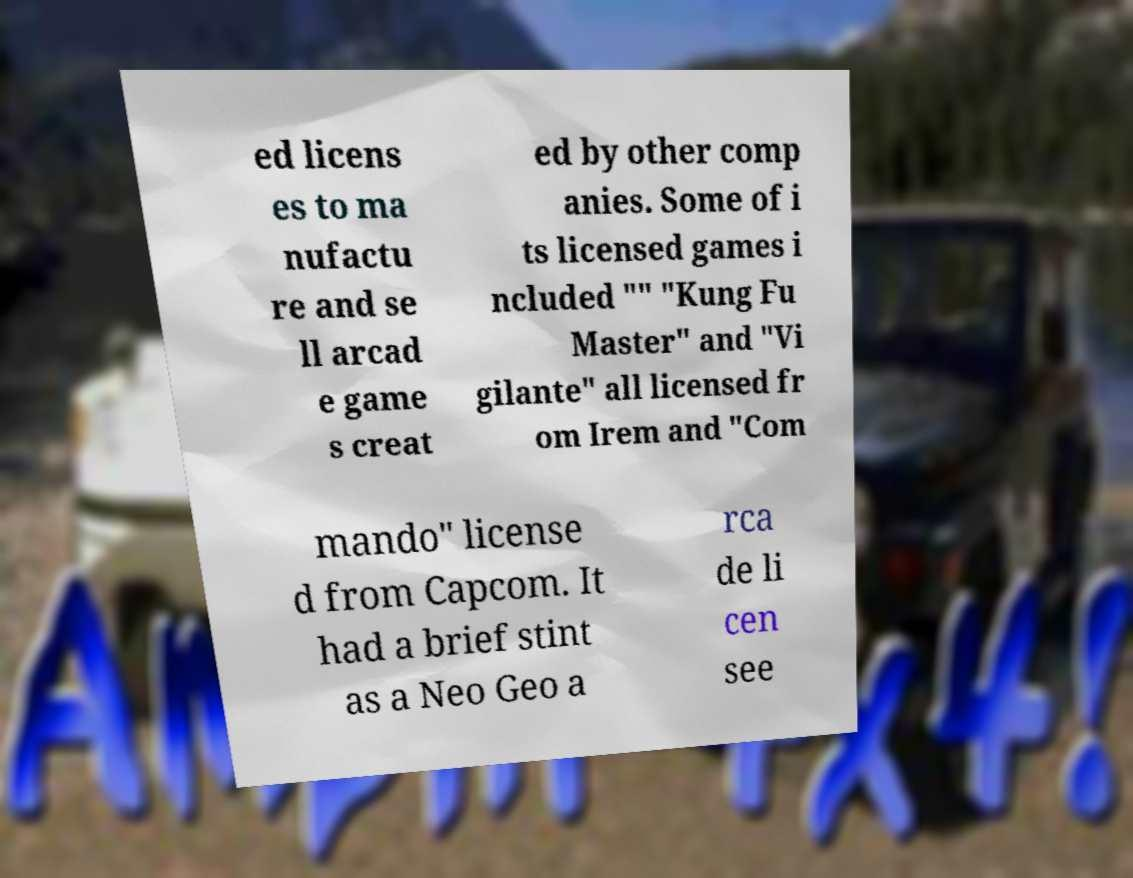What messages or text are displayed in this image? I need them in a readable, typed format. ed licens es to ma nufactu re and se ll arcad e game s creat ed by other comp anies. Some of i ts licensed games i ncluded "" "Kung Fu Master" and "Vi gilante" all licensed fr om Irem and "Com mando" license d from Capcom. It had a brief stint as a Neo Geo a rca de li cen see 